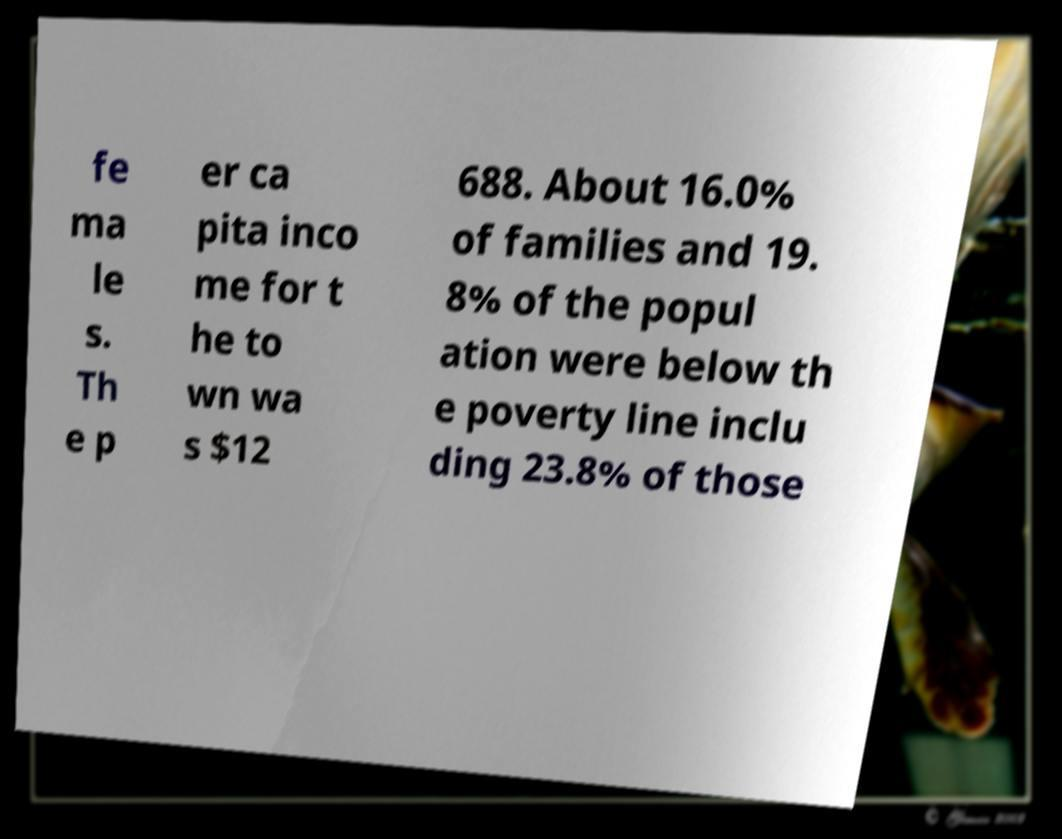Please read and relay the text visible in this image. What does it say? fe ma le s. Th e p er ca pita inco me for t he to wn wa s $12 688. About 16.0% of families and 19. 8% of the popul ation were below th e poverty line inclu ding 23.8% of those 